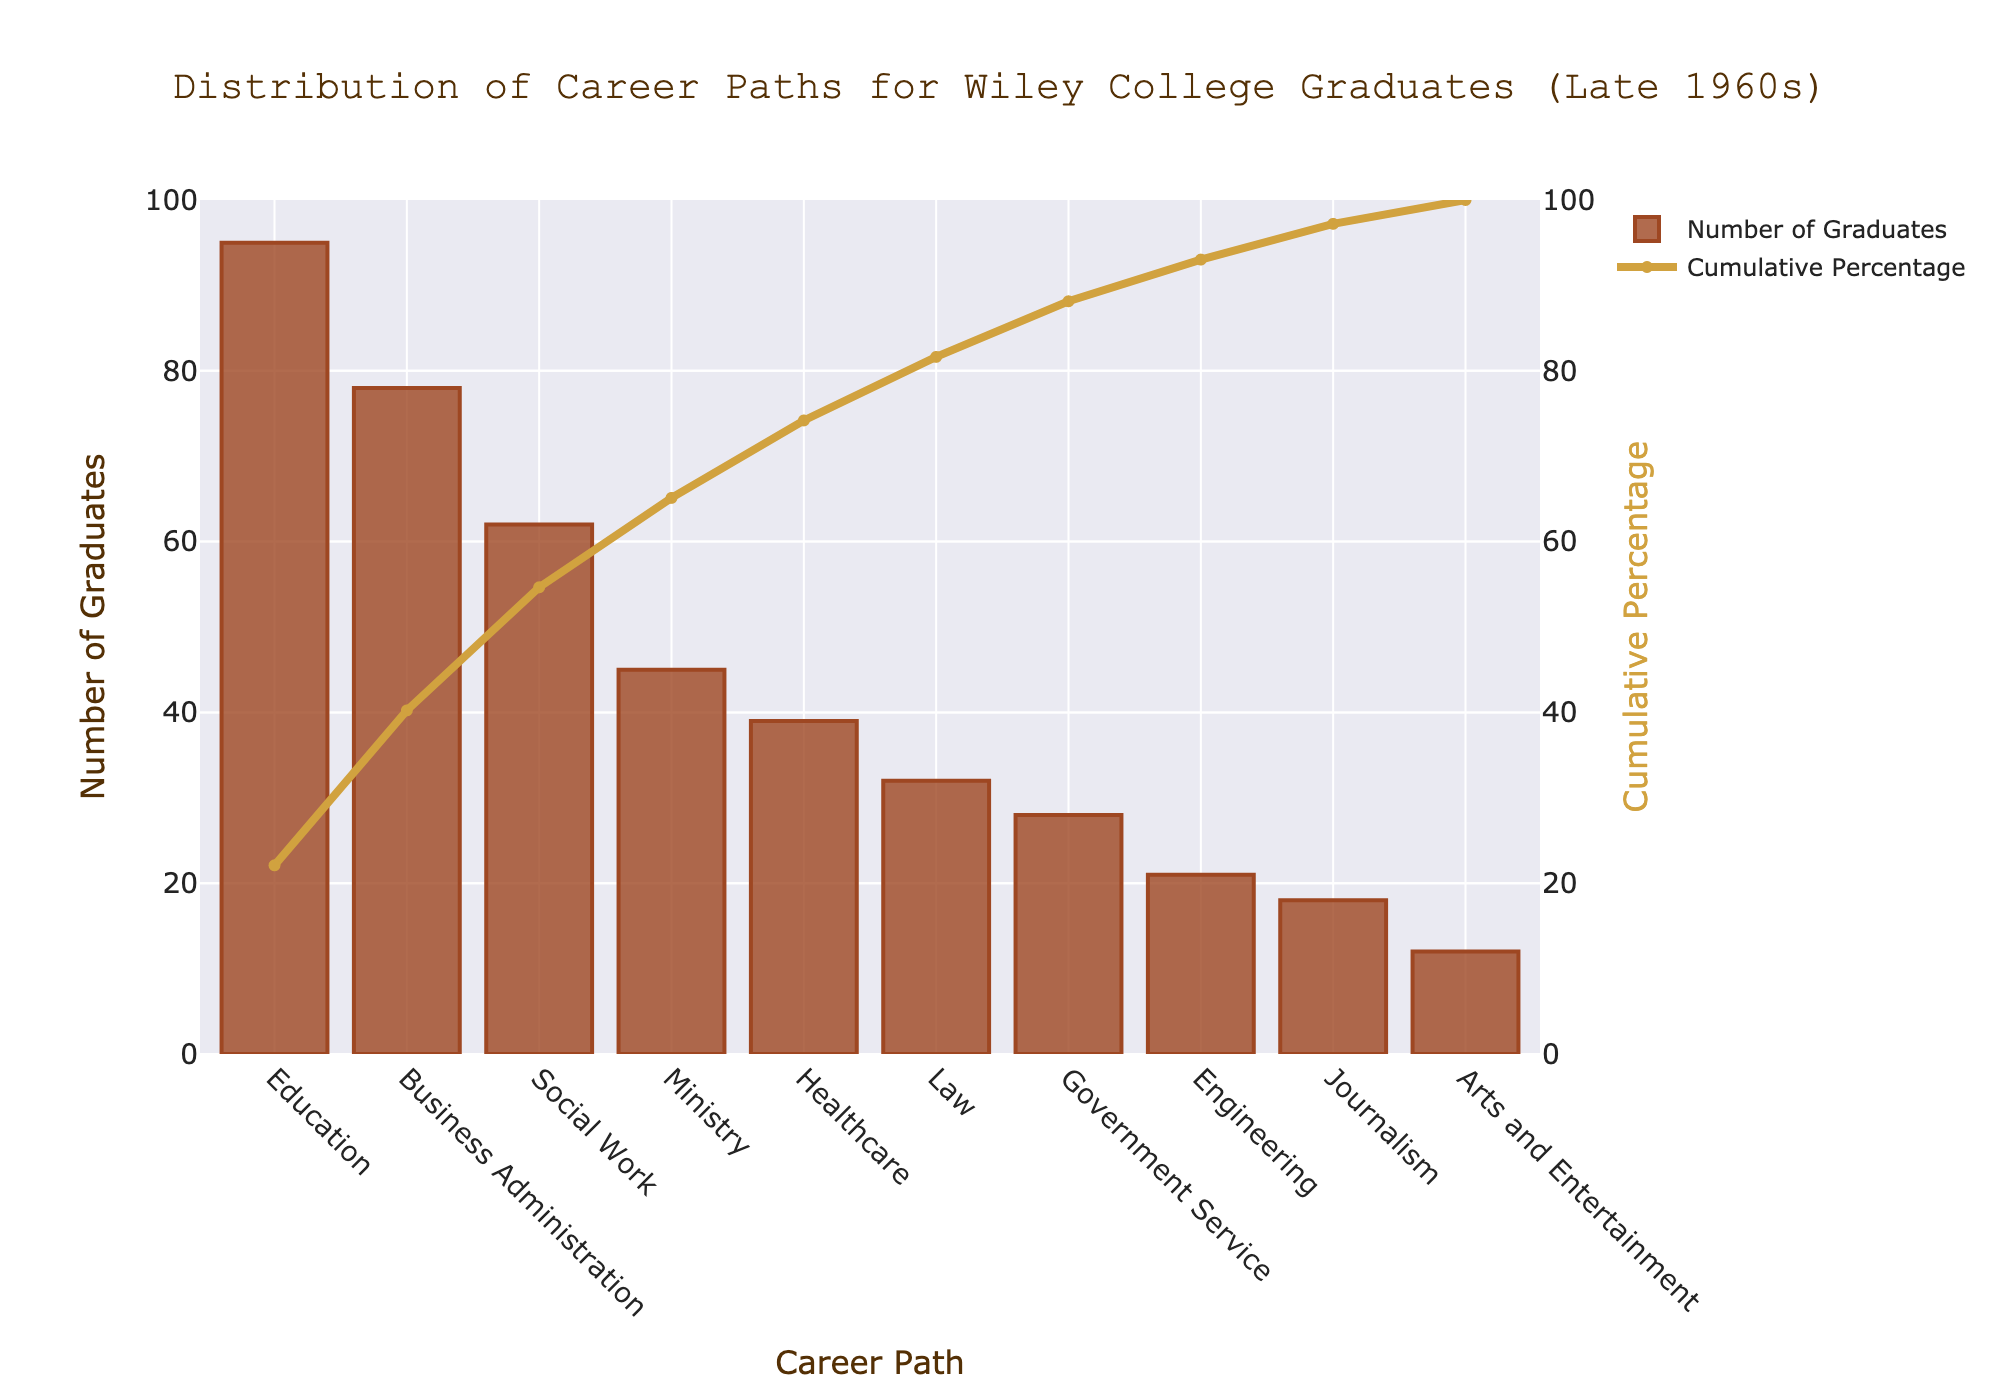what is the title of the chart? The title is located at the top center of the chart and it's written in a specified font and color
Answer: Distribution of Career Paths for Wiley College Graduates (Late 1960s) What career path has the highest number of graduates? The highest bar represents the career path with the most graduates
Answer: Education Which career path has the lowest number of graduates? The shortest bar represents the career path with the fewest graduates
Answer: Arts and Entertainment What is the cumulative percentage of graduates for the top three career paths? Sum the number of graduates for the top three career paths, divide by the total number of graduates, and multiply by 100. Top three: Education (95), Business Administration (78), and Social Work (62). Total graduates = 430. Cumulative percentage = (95 + 78 + 62) / 430 * 100
Answer: 55.3% Which career path has a higher cumulative percentage, Ministry or Law? Look at the cumulative percentage trace. Identify the points for Ministry (45 graduates) and Law (32 graduates). Compare the cumulative percentages at these points. Ministry is higher than Law
Answer: Ministry How many graduates chose a career in Engineering? Find the bar labeled Engineering and read the number of graduates directly from the y-axis
Answer: 21 What percentage of graduates chose a career path in Healthcare? Identify the number of graduates in Healthcare (39) and divide by total graduates (430), then multiply by 100
Answer: 9.07% How many more graduates chose Business Administration over Law? Subtract the number of Law graduates from Business Administration graduates (78 - 32)
Answer: 46 What is the range of the cumulative percentages shown on the right y-axis? The range is from the lowest to the highest value on the right y-axis
Answer: 0% to 100% What number of graduates or percentage does the chart’s cumulative percentage line reach first above 80%? The cumulative percentage line rises as you move right. Identify the career path that first pushes the cumulative line above 80%.
Answer: Government Service (82.33%) 